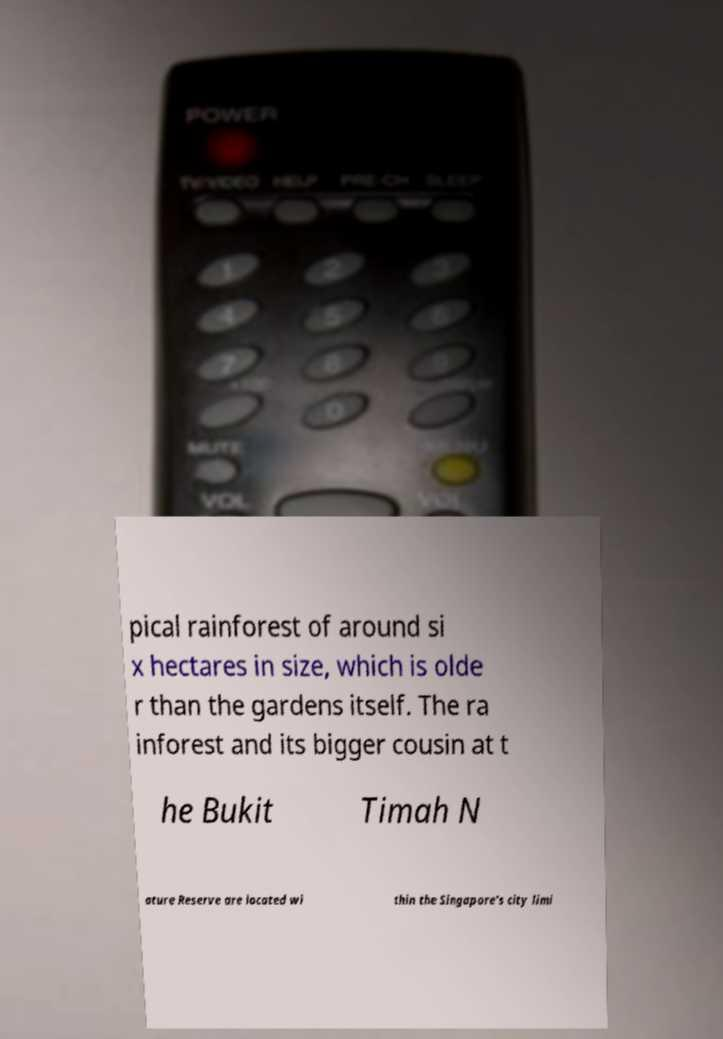Please identify and transcribe the text found in this image. pical rainforest of around si x hectares in size, which is olde r than the gardens itself. The ra inforest and its bigger cousin at t he Bukit Timah N ature Reserve are located wi thin the Singapore's city limi 